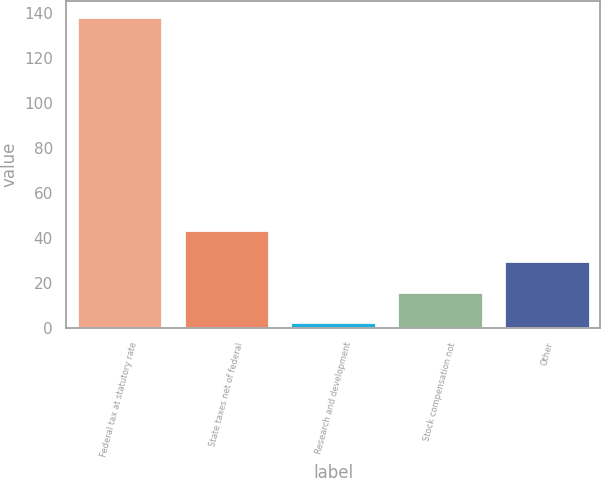Convert chart. <chart><loc_0><loc_0><loc_500><loc_500><bar_chart><fcel>Federal tax at statutory rate<fcel>State taxes net of federal<fcel>Research and development<fcel>Stock compensation not<fcel>Other<nl><fcel>138.6<fcel>43.4<fcel>2.6<fcel>16.2<fcel>29.8<nl></chart> 